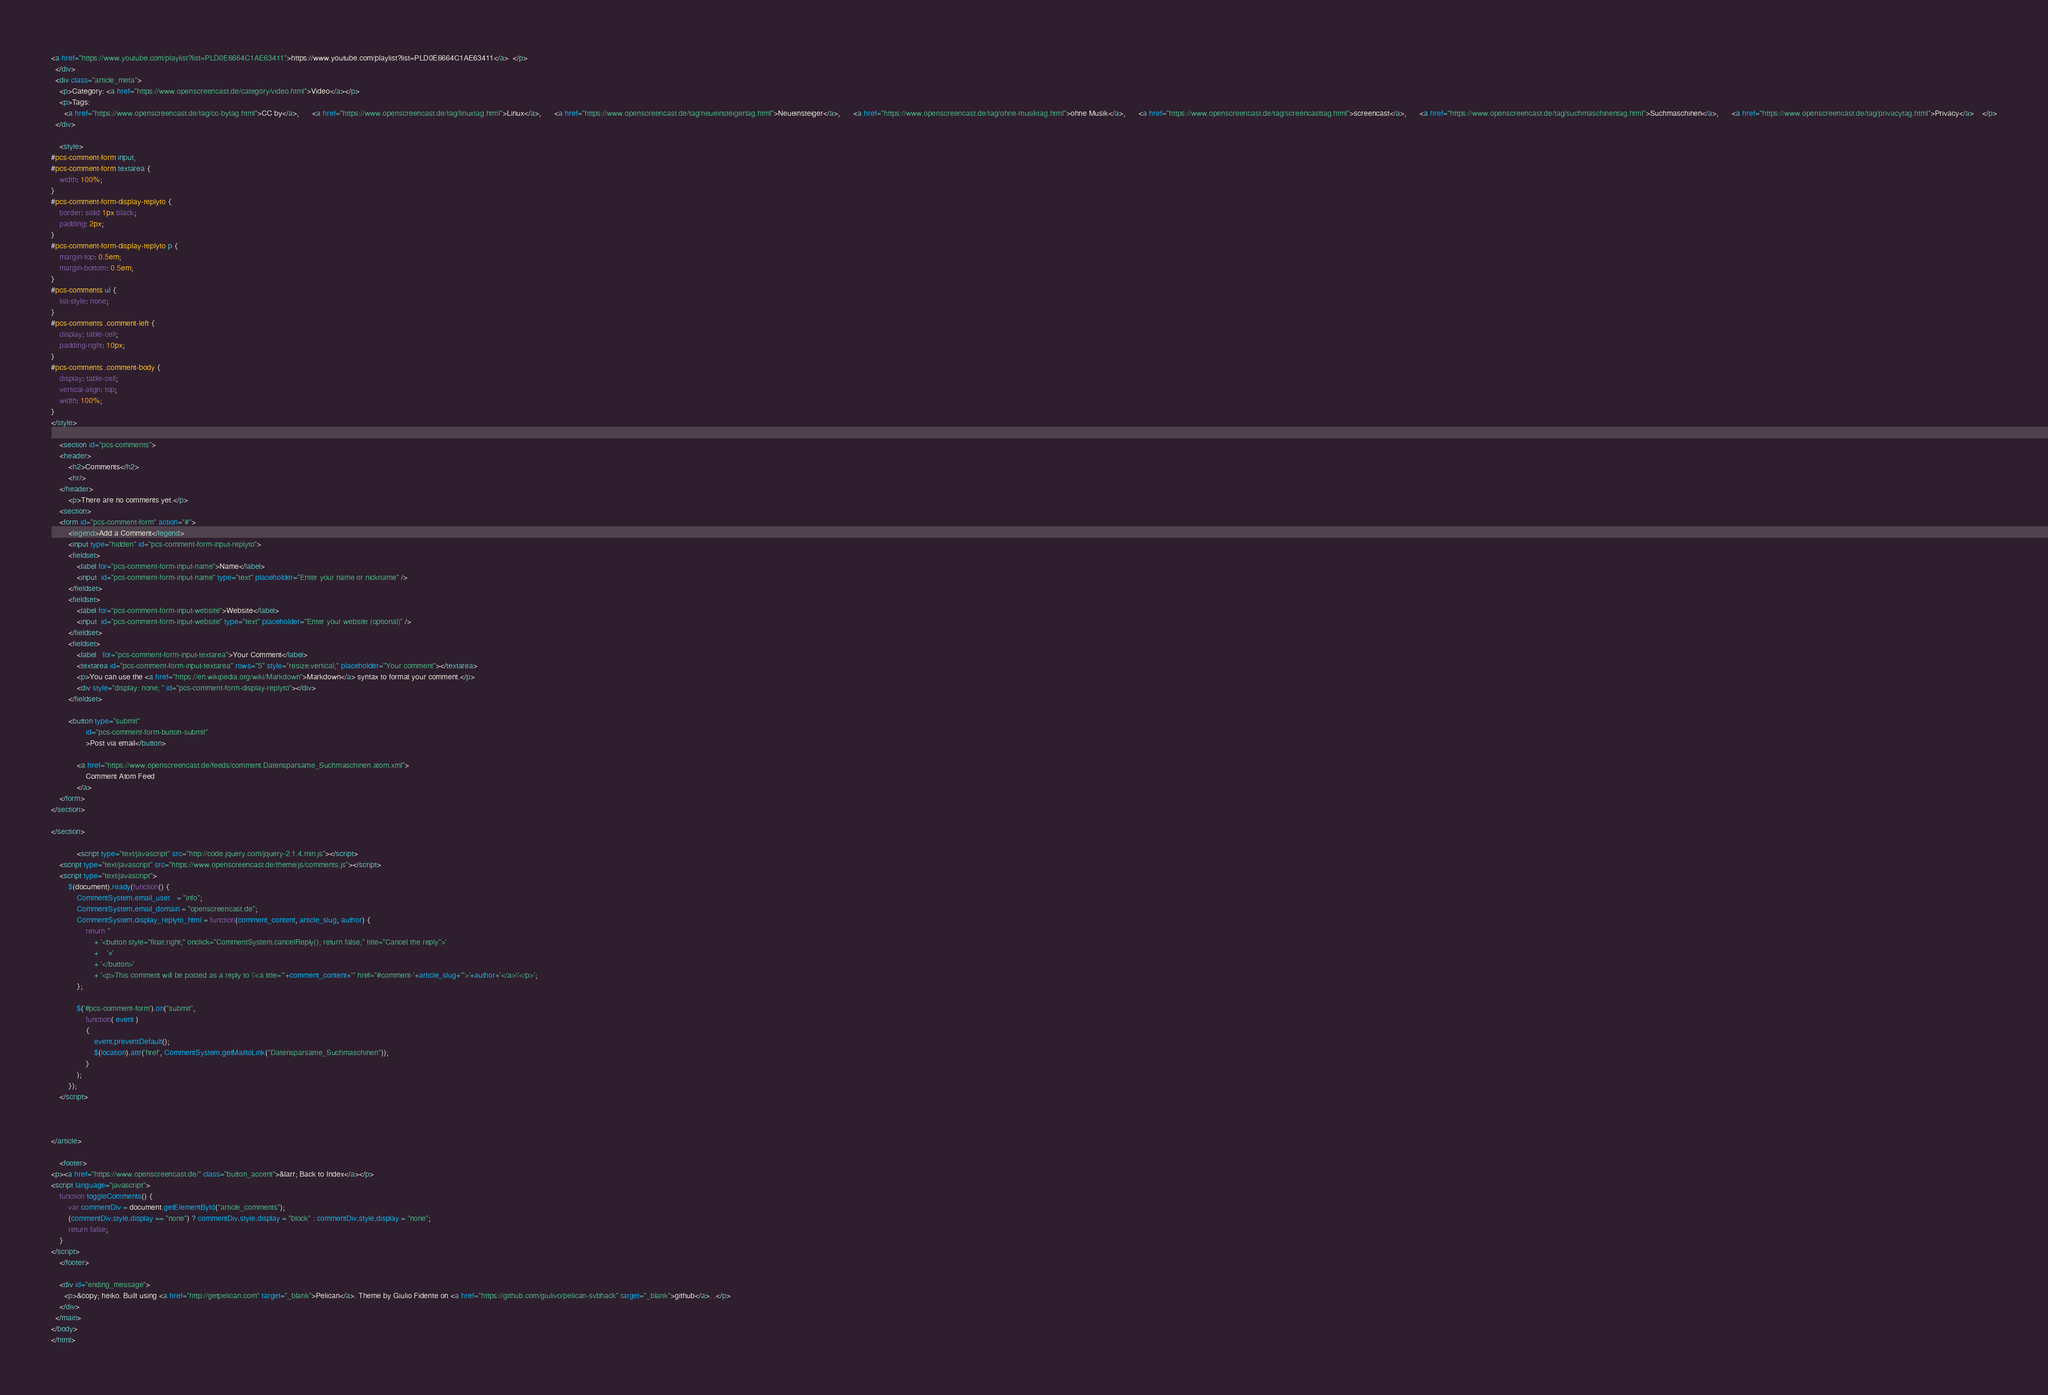<code> <loc_0><loc_0><loc_500><loc_500><_HTML_><a href="https://www.youtube.com/playlist?list=PLD0E6664C1AE63411">https://www.youtube.com/playlist?list=PLD0E6664C1AE63411</a>  </p>
  </div>
  <div class="article_meta">
    <p>Category: <a href="https://www.openscreencast.de/category/video.html">Video</a></p>
    <p>Tags:
      <a href="https://www.openscreencast.de/tag/cc-bytag.html">CC by</a>,      <a href="https://www.openscreencast.de/tag/linuxtag.html">Linux</a>,      <a href="https://www.openscreencast.de/tag/neueinsteigertag.html">Neueinsteiger</a>,      <a href="https://www.openscreencast.de/tag/ohne-musiktag.html">ohne Musik</a>,      <a href="https://www.openscreencast.de/tag/screencasttag.html">screencast</a>,      <a href="https://www.openscreencast.de/tag/suchmaschinentag.html">Suchmaschinen</a>,      <a href="https://www.openscreencast.de/tag/privacytag.html">Privacy</a>    </p>
  </div>

  	<style>
#pcs-comment-form input,
#pcs-comment-form textarea {
	width: 100%;
}
#pcs-comment-form-display-replyto {
	border: solid 1px black;
	padding: 2px;
}
#pcs-comment-form-display-replyto p {
	margin-top: 0.5em;
	margin-bottom: 0.5em;
}
#pcs-comments ul {
	list-style: none;
}
#pcs-comments .comment-left {
	display: table-cell;
	padding-right: 10px;
}
#pcs-comments .comment-body {
	display: table-cell;
	vertical-align: top;
	width: 100%;
}
</style>

	<section id="pcs-comments">
	<header>
		<h2>Comments</h2>
		<hr/>
	</header>
		<p>There are no comments yet.</p>
	<section>
	<form id="pcs-comment-form" action="#">
		<legend>Add a Comment</legend>
		<input type="hidden" id="pcs-comment-form-input-replyto">
		<fieldset>
			<label for="pcs-comment-form-input-name">Name</label>
			<input  id="pcs-comment-form-input-name" type="text" placeholder="Enter your name or nickname" />
		</fieldset>
		<fieldset>
			<label for="pcs-comment-form-input-website">Website</label>
			<input  id="pcs-comment-form-input-website" type="text" placeholder="Enter your website (optional)" />
		</fieldset>
		<fieldset>
			<label   for="pcs-comment-form-input-textarea">Your Comment</label>
			<textarea id="pcs-comment-form-input-textarea" rows="5" style="resize:vertical;" placeholder="Your comment"></textarea>
			<p>You can use the <a href="https://en.wikipedia.org/wiki/Markdown">Markdown</a> syntax to format your comment.</p>
			<div style="display: none; " id="pcs-comment-form-display-replyto"></div>
		</fieldset>

		<button type="submit"
				id="pcs-comment-form-button-submit"
				>Post via email</button>

			<a href="https://www.openscreencast.de/feeds/comment.Datensparsame_Suchmaschinen.atom.xml">
				Comment Atom Feed
			</a>
	</form>
</section>

</section>

			<script type="text/javascript" src="http://code.jquery.com/jquery-2.1.4.min.js"></script>
	<script type="text/javascript" src="https://www.openscreencast.de/theme/js/comments.js"></script>
	<script type="text/javascript">
		$(document).ready(function() {
			CommentSystem.email_user   = "info";
			CommentSystem.email_domain = "openscreencast.de";
			CommentSystem.display_replyto_html = function(comment_content, article_slug, author) { 
				return ''
					+ '<button style="float:right;" onclick="CommentSystem.cancelReply(); return false;" title="Cancel the reply">'
					+ 	'×'
					+ '</button>'
					+ '<p>This comment will be posted as a reply to \'<a title="'+comment_content+'" href="#comment-'+article_slug+'">'+author+'</a>\'</p>';
			};

			$('#pcs-comment-form').on("submit",
				function( event )
				{
					event.preventDefault();
					$(location).attr('href', CommentSystem.getMailtoLink("Datensparsame_Suchmaschinen"));
				}
			);
		});
	</script>



</article>

    <footer>
<p><a href="https://www.openscreencast.de/" class="button_accent">&larr; Back to Index</a></p>
<script language="javascript">
    function toggleComments() {
        var commentDiv = document.getElementById("article_comments");
        (commentDiv.style.display == "none") ? commentDiv.style.display = "block" : commentDiv.style.display = "none";
        return false;
    }
</script>
    </footer>

    <div id="ending_message">
      <p>&copy; heiko. Built using <a href="http://getpelican.com" target="_blank">Pelican</a>. Theme by Giulio Fidente on <a href="https://github.com/giulivo/pelican-svbhack" target="_blank">github</a>. .</p>
    </div>
  </main>
</body>
</html></code> 